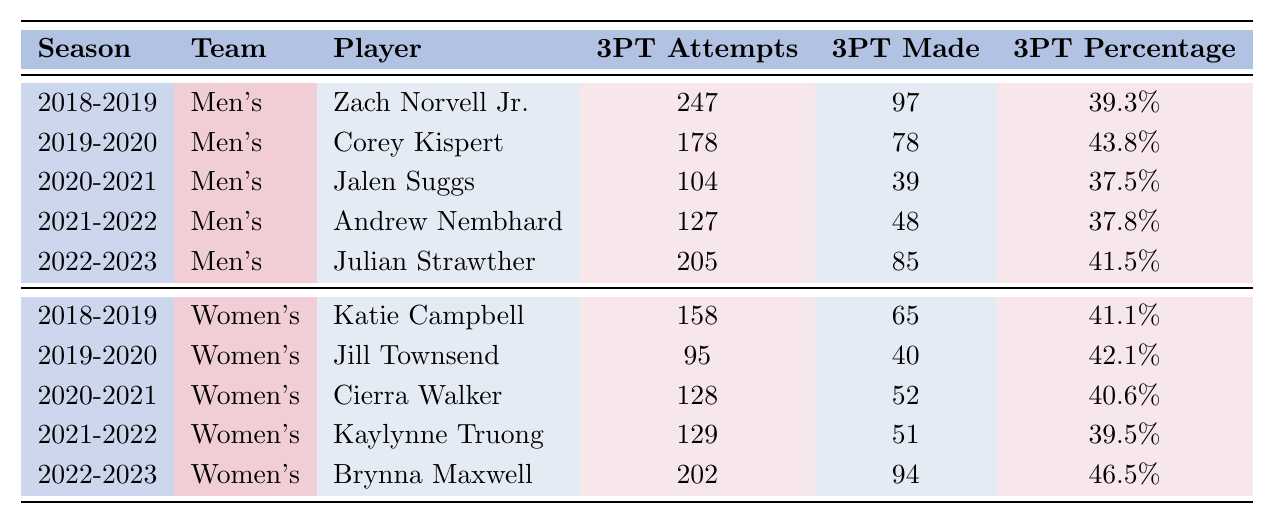What is the highest three-point shooting percentage among the men's players in the 2019-2020 season? In the 2019-2020 season, Corey Kispert had a three-point shooting percentage of 43.8%, which is the highest among the men's players listed for that season.
Answer: 43.8% Which women's player made the most three-point shots in the 2022-2023 season? In the 2022-2023 season, Brynna Maxwell made 94 three-point shots, which is the highest among the women's players for that season.
Answer: 94 What is the average three-point shooting percentage for the men's team across all seasons listed? The percentages for the men's team are 39.3%, 43.8%, 37.5%, 37.8%, and 41.5%. The average is calculated as (39.3 + 43.8 + 37.5 + 37.8 + 41.5) / 5 = 39.98%, rounded to two decimal places becomes 40.0%.
Answer: 40.0% Did any women's player have a three-point shooting percentage above 45% in the 2022-2023 season? Yes, Brynna Maxwell had a three-point shooting percentage of 46.5% in the 2022-2023 season, which is above 45%.
Answer: Yes Who had the lowest three-point shooting percentage among the men's players listed? The three-point shooting percentages for men's players are 39.3%, 43.8%, 37.5%, 37.8%, and 41.5%. The lowest percentage is 37.5% by Jalen Suggs in the 2020-2021 season.
Answer: 37.5% What is the total number of three-point attempts made by women's players in the 2018-2019 season? In the 2018-2019 season, Katie Campbell made 158 three-point attempts. There are no other women's players listed for that season, so the total is 158.
Answer: 158 Which team had a player with a shooting percentage of 39.5% or lower in the 2021-2022 season? In the 2021-2022 season, Kaylynne Truong from the women's team had a three-point shooting percentage of 39.5%. Andrew Nembhard from the men's team had a shooting percentage of 37.8%, which is also 39.5% or lower.
Answer: Both teams Can you identify a season where the men's team's player had a better shooting percentage than the women's player's best shooting percentage? Yes, in the 2019-2020 season, Corey Kispert from the men's team had a shooting percentage of 43.8%, which is higher than the best percentage for the women’s team that season, which was Jill Townsend at 42.1%.
Answer: Yes What is the total number of three-point shots made by the women's players across all seasons? The total made by women's players is 65, 40, 52, 51, and 94, which adds up to 302 (65 + 40 + 52 + 51 + 94 = 302).
Answer: 302 Is there any season where both teams had a player with a three-point shooting percentage equal to or above 40%? Yes, in the 2022-2023 season, both Julian Strawther (41.5%) from the men's team and Brynna Maxwell (46.5%) from the women's team had shooting percentages above 40%.
Answer: Yes 